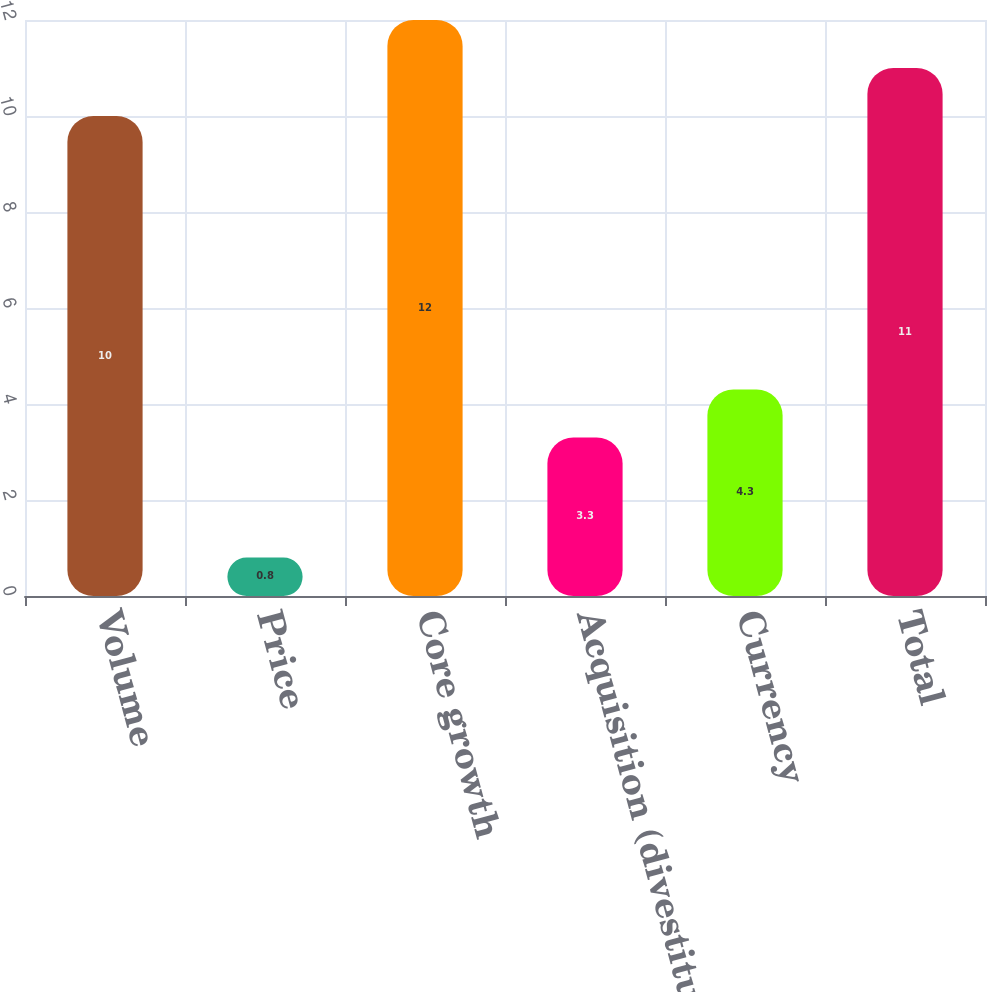Convert chart to OTSL. <chart><loc_0><loc_0><loc_500><loc_500><bar_chart><fcel>Volume<fcel>Price<fcel>Core growth<fcel>Acquisition (divestiture)<fcel>Currency<fcel>Total<nl><fcel>10<fcel>0.8<fcel>12<fcel>3.3<fcel>4.3<fcel>11<nl></chart> 